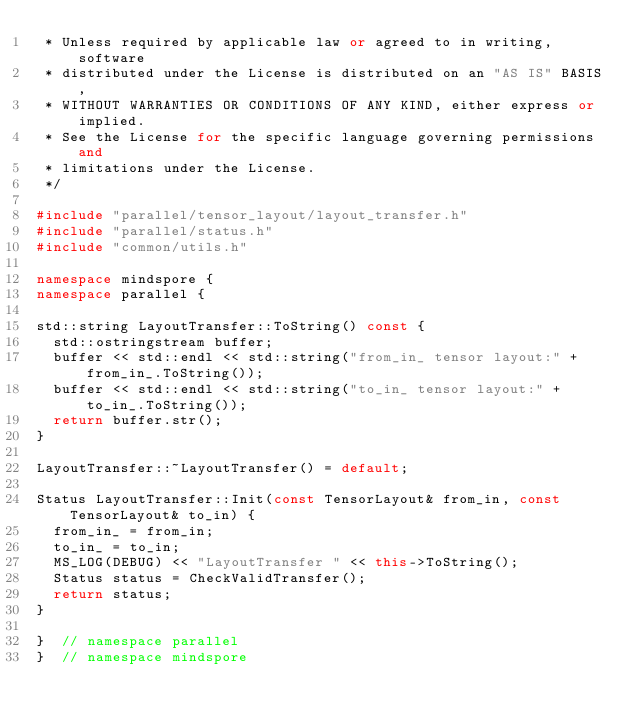<code> <loc_0><loc_0><loc_500><loc_500><_C++_> * Unless required by applicable law or agreed to in writing, software
 * distributed under the License is distributed on an "AS IS" BASIS,
 * WITHOUT WARRANTIES OR CONDITIONS OF ANY KIND, either express or implied.
 * See the License for the specific language governing permissions and
 * limitations under the License.
 */

#include "parallel/tensor_layout/layout_transfer.h"
#include "parallel/status.h"
#include "common/utils.h"

namespace mindspore {
namespace parallel {

std::string LayoutTransfer::ToString() const {
  std::ostringstream buffer;
  buffer << std::endl << std::string("from_in_ tensor layout:" + from_in_.ToString());
  buffer << std::endl << std::string("to_in_ tensor layout:" + to_in_.ToString());
  return buffer.str();
}

LayoutTransfer::~LayoutTransfer() = default;

Status LayoutTransfer::Init(const TensorLayout& from_in, const TensorLayout& to_in) {
  from_in_ = from_in;
  to_in_ = to_in;
  MS_LOG(DEBUG) << "LayoutTransfer " << this->ToString();
  Status status = CheckValidTransfer();
  return status;
}

}  // namespace parallel
}  // namespace mindspore
</code> 